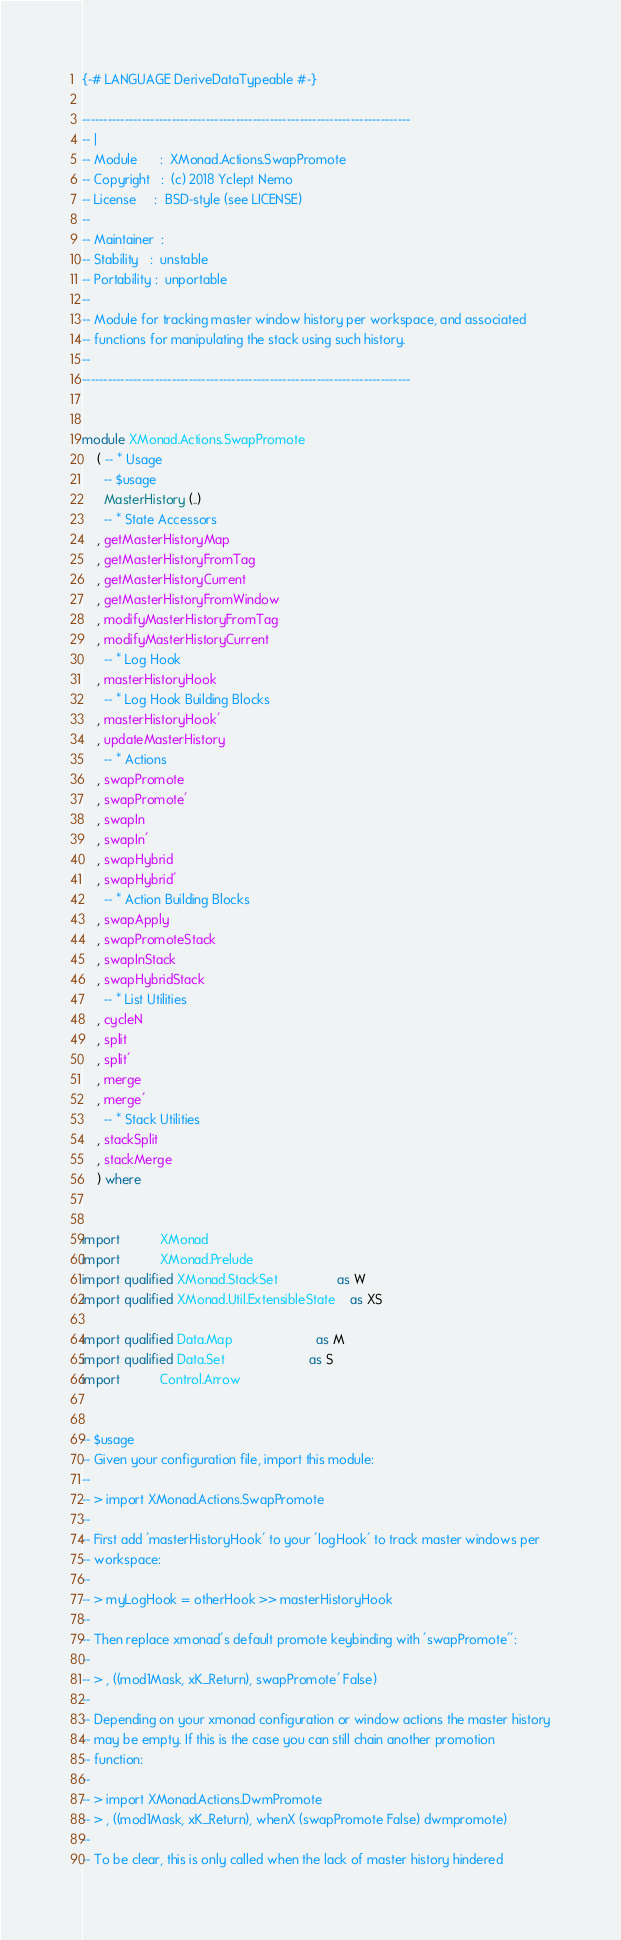<code> <loc_0><loc_0><loc_500><loc_500><_Haskell_>{-# LANGUAGE DeriveDataTypeable #-}

-----------------------------------------------------------------------------
-- |
-- Module      :  XMonad.Actions.SwapPromote
-- Copyright   :  (c) 2018 Yclept Nemo
-- License     :  BSD-style (see LICENSE)
--
-- Maintainer  :
-- Stability   :  unstable
-- Portability :  unportable
--
-- Module for tracking master window history per workspace, and associated
-- functions for manipulating the stack using such history.
--
-----------------------------------------------------------------------------


module XMonad.Actions.SwapPromote
    ( -- * Usage
      -- $usage
      MasterHistory (..)
      -- * State Accessors
    , getMasterHistoryMap
    , getMasterHistoryFromTag
    , getMasterHistoryCurrent
    , getMasterHistoryFromWindow
    , modifyMasterHistoryFromTag
    , modifyMasterHistoryCurrent
      -- * Log Hook
    , masterHistoryHook
      -- * Log Hook Building Blocks
    , masterHistoryHook'
    , updateMasterHistory
      -- * Actions
    , swapPromote
    , swapPromote'
    , swapIn
    , swapIn'
    , swapHybrid
    , swapHybrid'
      -- * Action Building Blocks
    , swapApply
    , swapPromoteStack
    , swapInStack
    , swapHybridStack
      -- * List Utilities
    , cycleN
    , split
    , split'
    , merge
    , merge'
      -- * Stack Utilities
    , stackSplit
    , stackMerge
    ) where


import           XMonad
import           XMonad.Prelude
import qualified XMonad.StackSet                as W
import qualified XMonad.Util.ExtensibleState    as XS

import qualified Data.Map                       as M
import qualified Data.Set                       as S
import           Control.Arrow


-- $usage
-- Given your configuration file, import this module:
--
-- > import XMonad.Actions.SwapPromote
--
-- First add 'masterHistoryHook' to your 'logHook' to track master windows per
-- workspace:
--
-- > myLogHook = otherHook >> masterHistoryHook
--
-- Then replace xmonad's default promote keybinding with 'swapPromote'':
--
-- > , ((mod1Mask, xK_Return), swapPromote' False)
--
-- Depending on your xmonad configuration or window actions the master history
-- may be empty. If this is the case you can still chain another promotion
-- function:
--
-- > import XMonad.Actions.DwmPromote
-- > , ((mod1Mask, xK_Return), whenX (swapPromote False) dwmpromote)
--
-- To be clear, this is only called when the lack of master history hindered</code> 